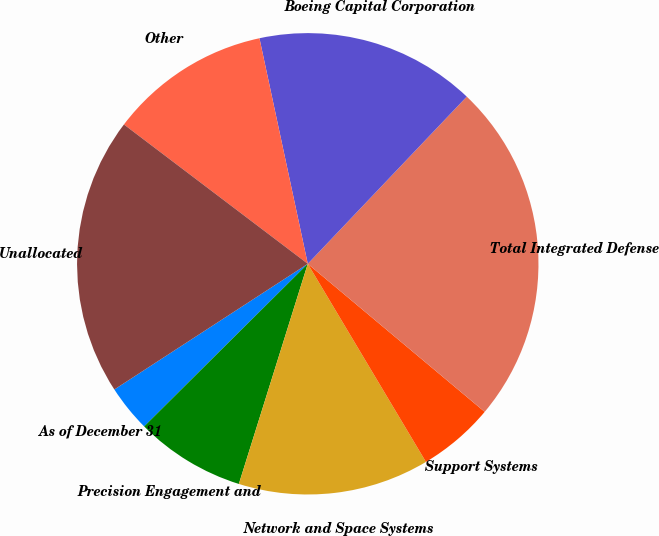<chart> <loc_0><loc_0><loc_500><loc_500><pie_chart><fcel>As of December 31<fcel>Precision Engagement and<fcel>Network and Space Systems<fcel>Support Systems<fcel>Total Integrated Defense<fcel>Boeing Capital Corporation<fcel>Other<fcel>Unallocated<nl><fcel>3.28%<fcel>7.72%<fcel>13.39%<fcel>5.35%<fcel>23.99%<fcel>15.46%<fcel>11.32%<fcel>19.49%<nl></chart> 